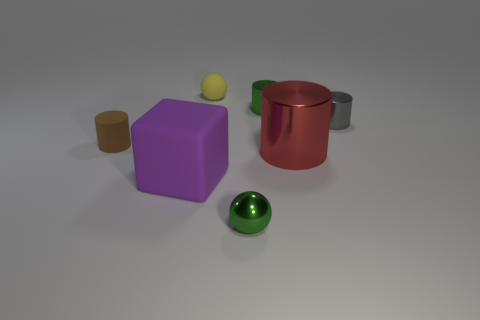Are there any green shiny balls that have the same size as the brown thing?
Provide a short and direct response. Yes. There is a big object on the right side of the green metal cylinder; what color is it?
Provide a short and direct response. Red. There is a big thing that is on the left side of the red cylinder; is there a purple rubber thing that is to the left of it?
Offer a terse response. No. What number of other things are there of the same color as the big shiny thing?
Give a very brief answer. 0. Does the cylinder left of the small matte ball have the same size as the green metal object behind the gray object?
Give a very brief answer. Yes. There is a matte thing that is behind the gray metal cylinder that is right of the rubber cube; how big is it?
Your response must be concise. Small. The small cylinder that is to the right of the tiny brown rubber cylinder and to the left of the gray thing is made of what material?
Your response must be concise. Metal. What color is the large matte thing?
Your answer should be very brief. Purple. Are there any other things that have the same material as the tiny brown cylinder?
Keep it short and to the point. Yes. What shape is the green metallic thing to the right of the tiny green sphere?
Keep it short and to the point. Cylinder. 